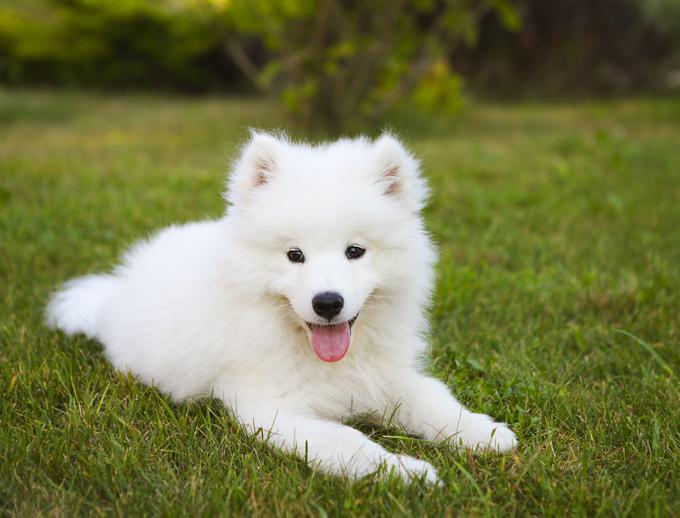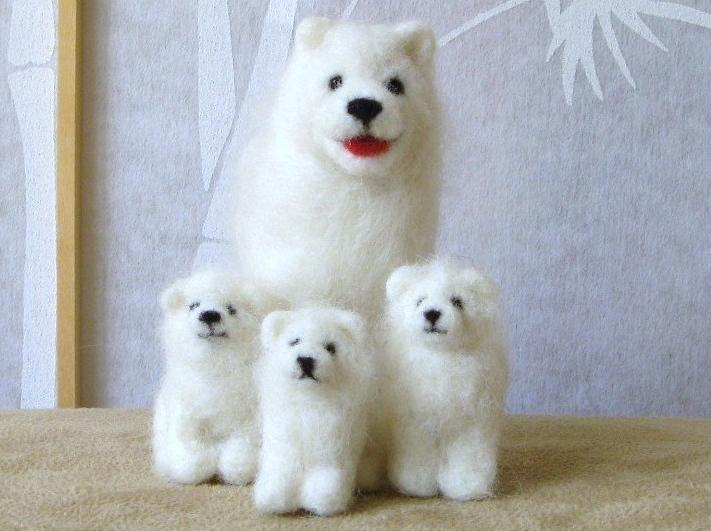The first image is the image on the left, the second image is the image on the right. For the images displayed, is the sentence "In one image there is a dog outside in the center of the image." factually correct? Answer yes or no. Yes. The first image is the image on the left, the second image is the image on the right. Examine the images to the left and right. Is the description "At least one dog's tongue is visible." accurate? Answer yes or no. Yes. 